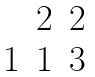Convert formula to latex. <formula><loc_0><loc_0><loc_500><loc_500>\begin{matrix} & 2 & 2 \\ 1 & 1 & 3 \end{matrix}</formula> 